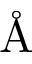Convert formula to latex. <formula><loc_0><loc_0><loc_500><loc_500>\AA</formula> 